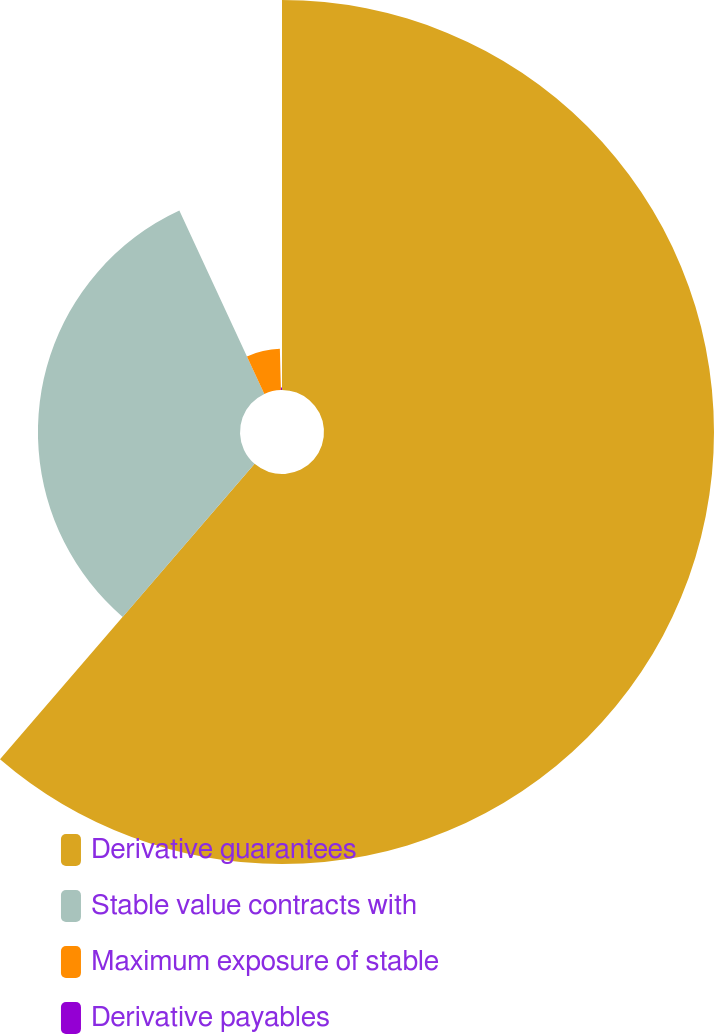Convert chart to OTSL. <chart><loc_0><loc_0><loc_500><loc_500><pie_chart><fcel>Derivative guarantees<fcel>Stable value contracts with<fcel>Maximum exposure of stable<fcel>Derivative payables<nl><fcel>61.32%<fcel>31.77%<fcel>6.5%<fcel>0.41%<nl></chart> 